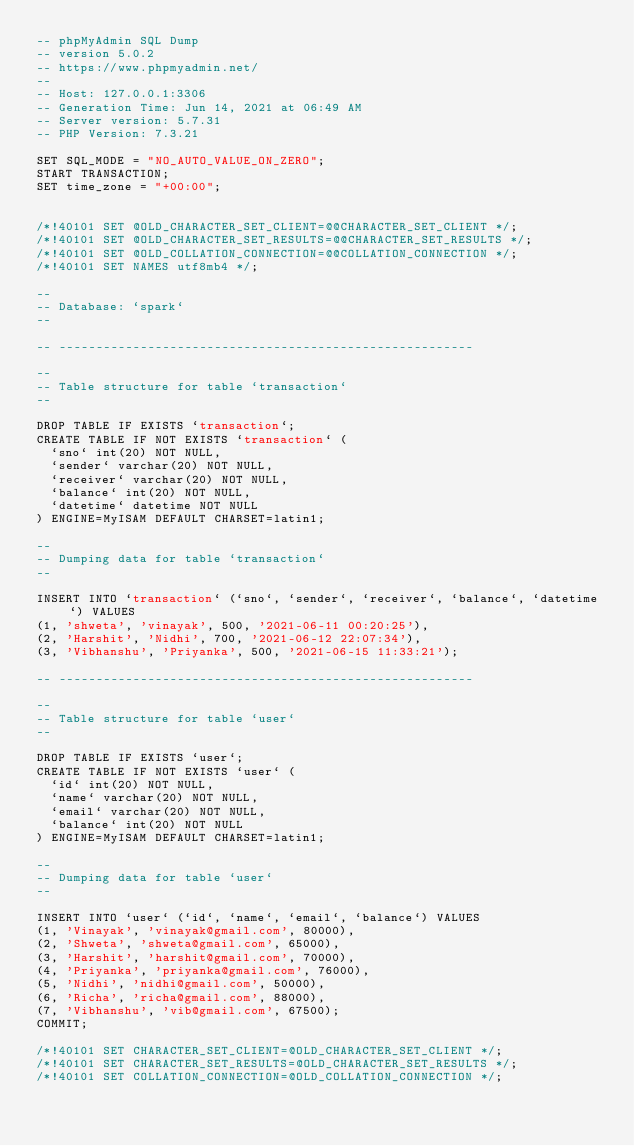Convert code to text. <code><loc_0><loc_0><loc_500><loc_500><_SQL_>-- phpMyAdmin SQL Dump
-- version 5.0.2
-- https://www.phpmyadmin.net/
--
-- Host: 127.0.0.1:3306
-- Generation Time: Jun 14, 2021 at 06:49 AM
-- Server version: 5.7.31
-- PHP Version: 7.3.21

SET SQL_MODE = "NO_AUTO_VALUE_ON_ZERO";
START TRANSACTION;
SET time_zone = "+00:00";


/*!40101 SET @OLD_CHARACTER_SET_CLIENT=@@CHARACTER_SET_CLIENT */;
/*!40101 SET @OLD_CHARACTER_SET_RESULTS=@@CHARACTER_SET_RESULTS */;
/*!40101 SET @OLD_COLLATION_CONNECTION=@@COLLATION_CONNECTION */;
/*!40101 SET NAMES utf8mb4 */;

--
-- Database: `spark`
--

-- --------------------------------------------------------

--
-- Table structure for table `transaction`
--

DROP TABLE IF EXISTS `transaction`;
CREATE TABLE IF NOT EXISTS `transaction` (
  `sno` int(20) NOT NULL,
  `sender` varchar(20) NOT NULL,
  `receiver` varchar(20) NOT NULL,
  `balance` int(20) NOT NULL,
  `datetime` datetime NOT NULL
) ENGINE=MyISAM DEFAULT CHARSET=latin1;

--
-- Dumping data for table `transaction`
--

INSERT INTO `transaction` (`sno`, `sender`, `receiver`, `balance`, `datetime`) VALUES
(1, 'shweta', 'vinayak', 500, '2021-06-11 00:20:25'),
(2, 'Harshit', 'Nidhi', 700, '2021-06-12 22:07:34'),
(3, 'Vibhanshu', 'Priyanka', 500, '2021-06-15 11:33:21');

-- --------------------------------------------------------

--
-- Table structure for table `user`
--

DROP TABLE IF EXISTS `user`;
CREATE TABLE IF NOT EXISTS `user` (
  `id` int(20) NOT NULL,
  `name` varchar(20) NOT NULL,
  `email` varchar(20) NOT NULL,
  `balance` int(20) NOT NULL
) ENGINE=MyISAM DEFAULT CHARSET=latin1;

--
-- Dumping data for table `user`
--

INSERT INTO `user` (`id`, `name`, `email`, `balance`) VALUES
(1, 'Vinayak', 'vinayak@gmail.com', 80000),
(2, 'Shweta', 'shweta@gmail.com', 65000),
(3, 'Harshit', 'harshit@gmail.com', 70000),
(4, 'Priyanka', 'priyanka@gmail.com', 76000),
(5, 'Nidhi', 'nidhi@gmail.com', 50000),
(6, 'Richa', 'richa@gmail.com', 88000),
(7, 'Vibhanshu', 'vib@gmail.com', 67500);
COMMIT;

/*!40101 SET CHARACTER_SET_CLIENT=@OLD_CHARACTER_SET_CLIENT */;
/*!40101 SET CHARACTER_SET_RESULTS=@OLD_CHARACTER_SET_RESULTS */;
/*!40101 SET COLLATION_CONNECTION=@OLD_COLLATION_CONNECTION */;
</code> 